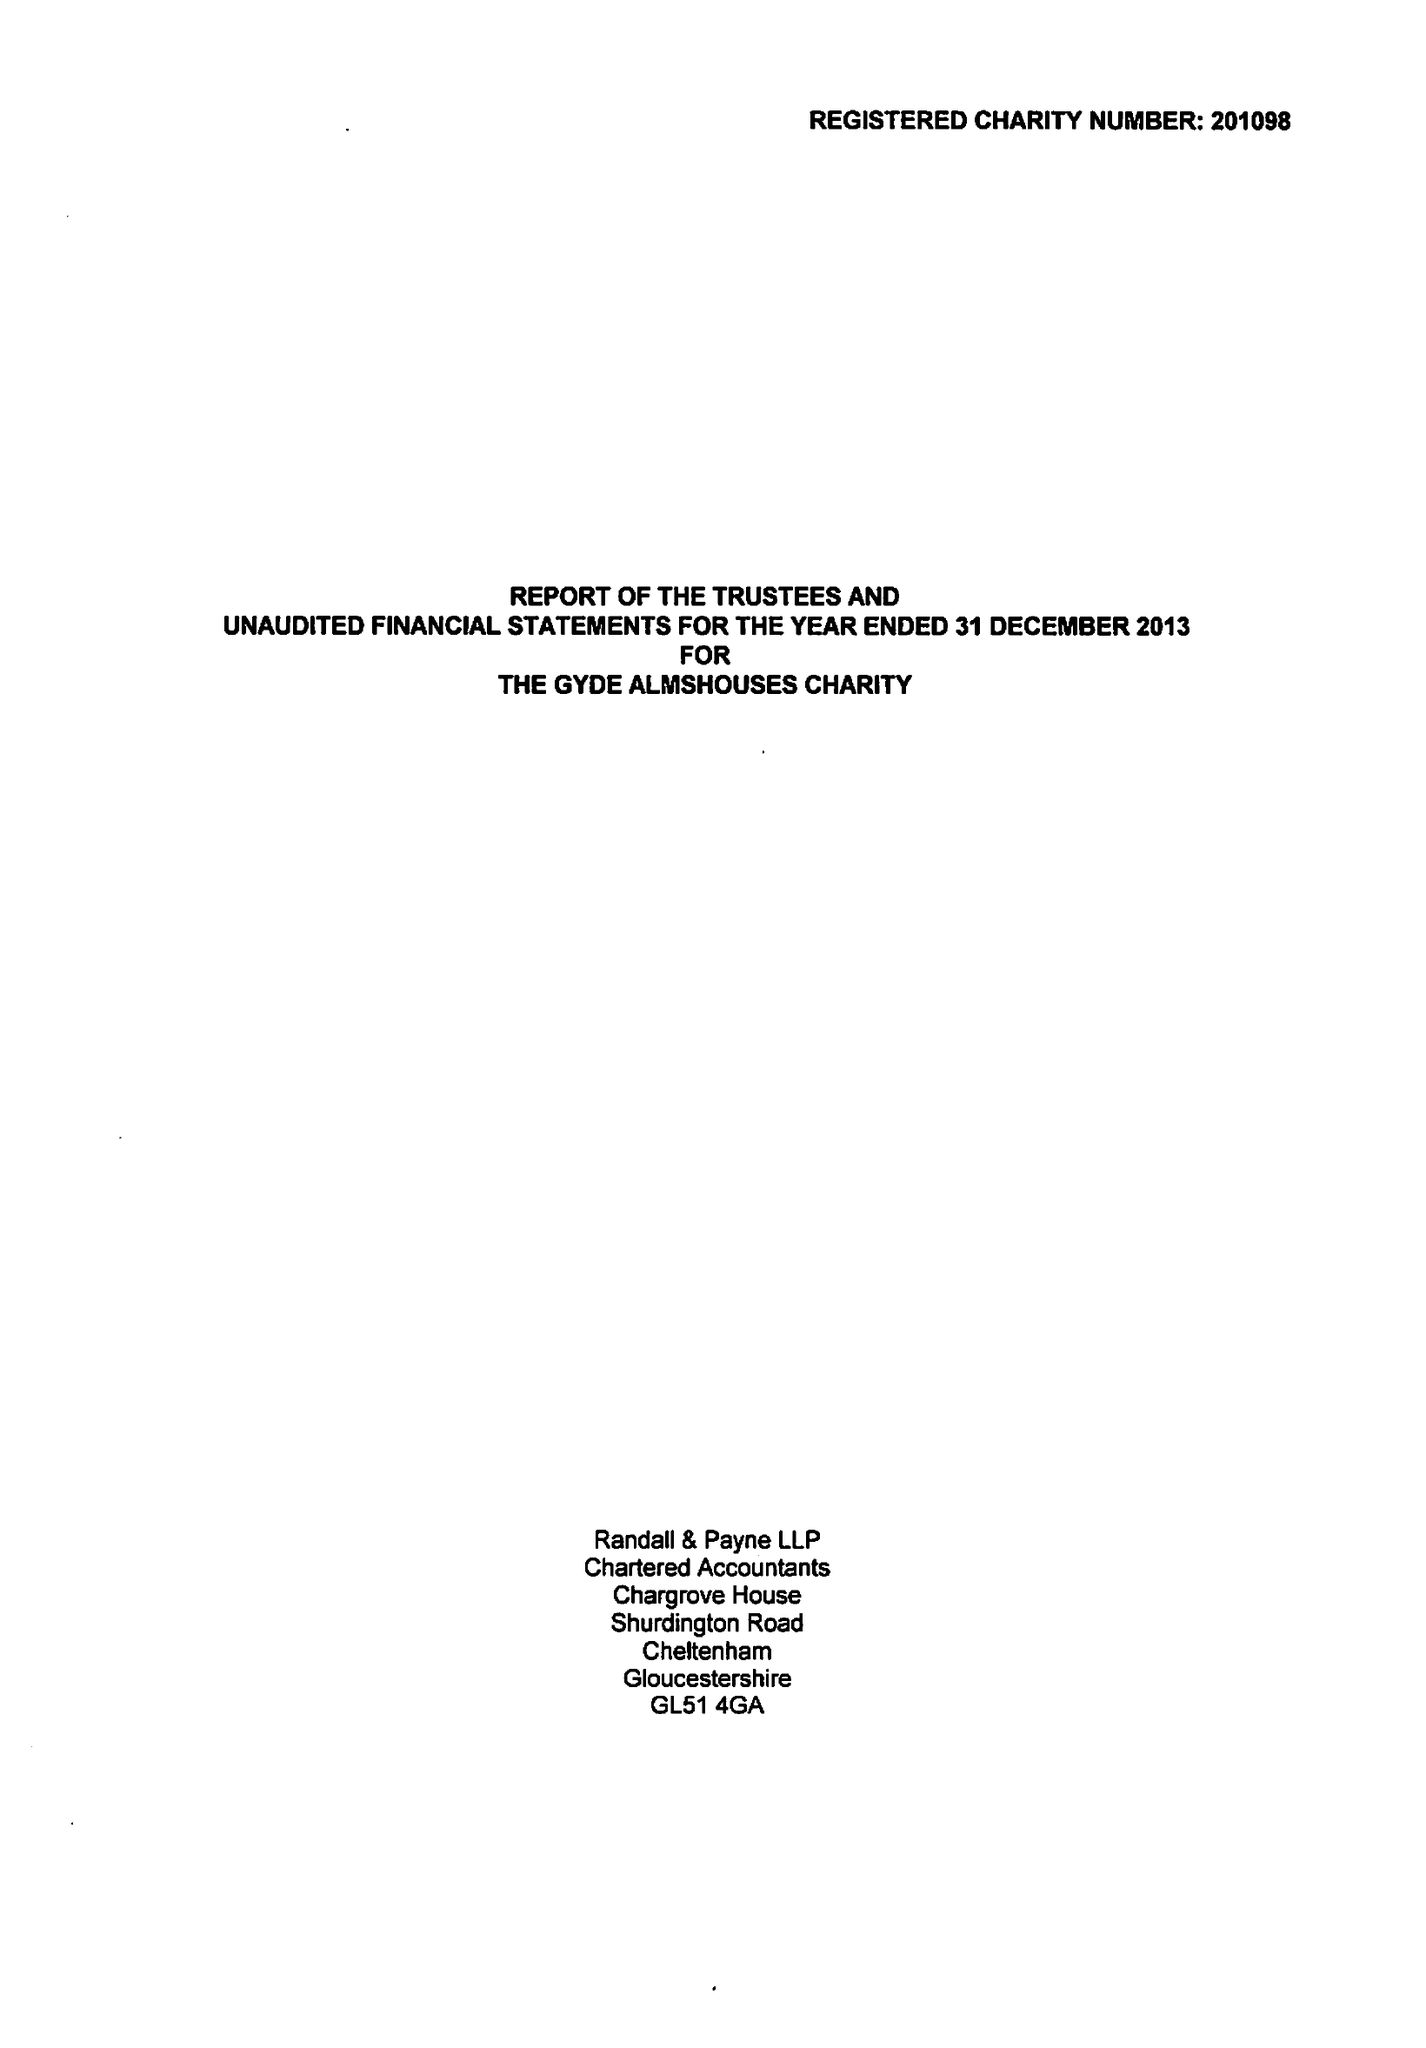What is the value for the charity_number?
Answer the question using a single word or phrase. 201098 